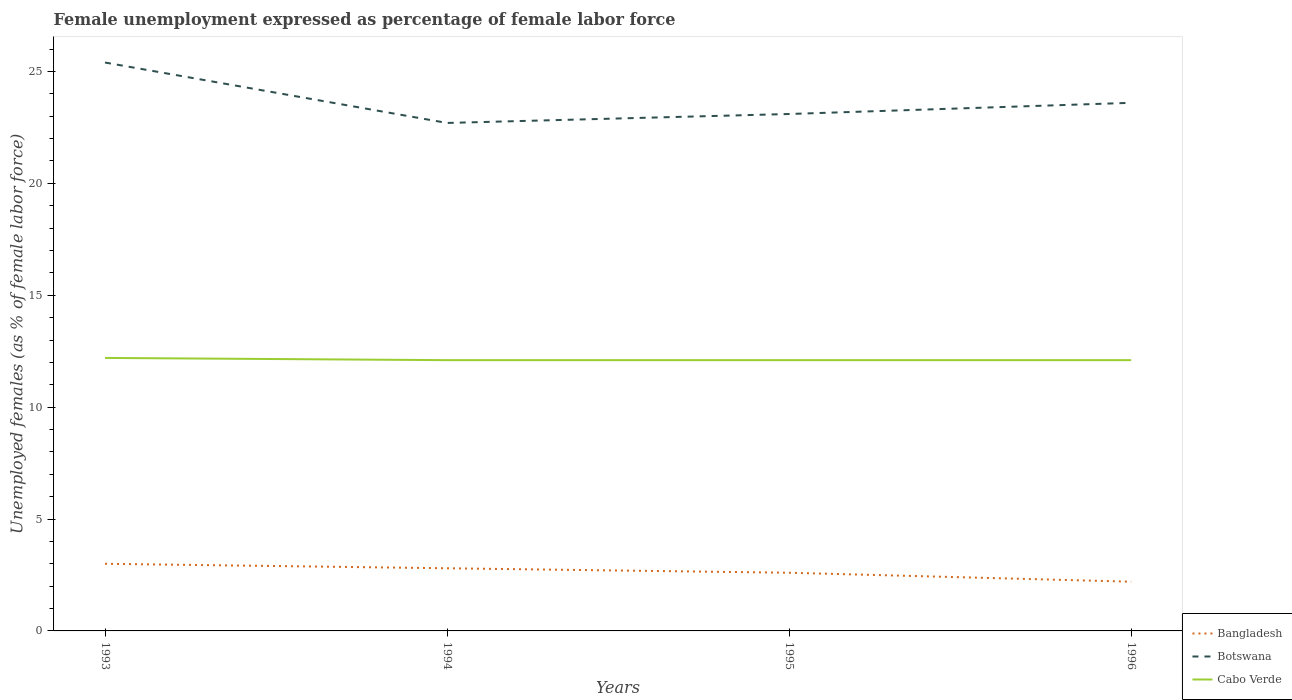Does the line corresponding to Bangladesh intersect with the line corresponding to Botswana?
Keep it short and to the point. No. Across all years, what is the maximum unemployment in females in in Cabo Verde?
Offer a terse response. 12.1. What is the total unemployment in females in in Botswana in the graph?
Keep it short and to the point. 1.8. What is the difference between the highest and the second highest unemployment in females in in Bangladesh?
Make the answer very short. 0.8. Is the unemployment in females in in Botswana strictly greater than the unemployment in females in in Cabo Verde over the years?
Keep it short and to the point. No. How many years are there in the graph?
Give a very brief answer. 4. How many legend labels are there?
Your response must be concise. 3. How are the legend labels stacked?
Your answer should be very brief. Vertical. What is the title of the graph?
Keep it short and to the point. Female unemployment expressed as percentage of female labor force. Does "Dominica" appear as one of the legend labels in the graph?
Offer a very short reply. No. What is the label or title of the X-axis?
Provide a short and direct response. Years. What is the label or title of the Y-axis?
Make the answer very short. Unemployed females (as % of female labor force). What is the Unemployed females (as % of female labor force) of Bangladesh in 1993?
Make the answer very short. 3. What is the Unemployed females (as % of female labor force) in Botswana in 1993?
Provide a short and direct response. 25.4. What is the Unemployed females (as % of female labor force) in Cabo Verde in 1993?
Your answer should be compact. 12.2. What is the Unemployed females (as % of female labor force) in Bangladesh in 1994?
Your answer should be compact. 2.8. What is the Unemployed females (as % of female labor force) in Botswana in 1994?
Provide a succinct answer. 22.7. What is the Unemployed females (as % of female labor force) of Cabo Verde in 1994?
Give a very brief answer. 12.1. What is the Unemployed females (as % of female labor force) of Bangladesh in 1995?
Your answer should be compact. 2.6. What is the Unemployed females (as % of female labor force) of Botswana in 1995?
Give a very brief answer. 23.1. What is the Unemployed females (as % of female labor force) of Cabo Verde in 1995?
Provide a succinct answer. 12.1. What is the Unemployed females (as % of female labor force) of Bangladesh in 1996?
Keep it short and to the point. 2.2. What is the Unemployed females (as % of female labor force) of Botswana in 1996?
Keep it short and to the point. 23.6. What is the Unemployed females (as % of female labor force) of Cabo Verde in 1996?
Keep it short and to the point. 12.1. Across all years, what is the maximum Unemployed females (as % of female labor force) in Botswana?
Provide a succinct answer. 25.4. Across all years, what is the maximum Unemployed females (as % of female labor force) in Cabo Verde?
Your answer should be compact. 12.2. Across all years, what is the minimum Unemployed females (as % of female labor force) of Bangladesh?
Make the answer very short. 2.2. Across all years, what is the minimum Unemployed females (as % of female labor force) of Botswana?
Make the answer very short. 22.7. Across all years, what is the minimum Unemployed females (as % of female labor force) in Cabo Verde?
Provide a succinct answer. 12.1. What is the total Unemployed females (as % of female labor force) in Botswana in the graph?
Provide a short and direct response. 94.8. What is the total Unemployed females (as % of female labor force) in Cabo Verde in the graph?
Make the answer very short. 48.5. What is the difference between the Unemployed females (as % of female labor force) of Bangladesh in 1993 and that in 1994?
Make the answer very short. 0.2. What is the difference between the Unemployed females (as % of female labor force) of Bangladesh in 1993 and that in 1995?
Keep it short and to the point. 0.4. What is the difference between the Unemployed females (as % of female labor force) in Botswana in 1993 and that in 1995?
Offer a very short reply. 2.3. What is the difference between the Unemployed females (as % of female labor force) of Cabo Verde in 1993 and that in 1996?
Offer a very short reply. 0.1. What is the difference between the Unemployed females (as % of female labor force) in Bangladesh in 1994 and that in 1995?
Make the answer very short. 0.2. What is the difference between the Unemployed females (as % of female labor force) of Bangladesh in 1994 and that in 1996?
Your answer should be very brief. 0.6. What is the difference between the Unemployed females (as % of female labor force) in Cabo Verde in 1995 and that in 1996?
Provide a succinct answer. 0. What is the difference between the Unemployed females (as % of female labor force) of Bangladesh in 1993 and the Unemployed females (as % of female labor force) of Botswana in 1994?
Make the answer very short. -19.7. What is the difference between the Unemployed females (as % of female labor force) of Botswana in 1993 and the Unemployed females (as % of female labor force) of Cabo Verde in 1994?
Offer a terse response. 13.3. What is the difference between the Unemployed females (as % of female labor force) of Bangladesh in 1993 and the Unemployed females (as % of female labor force) of Botswana in 1995?
Your response must be concise. -20.1. What is the difference between the Unemployed females (as % of female labor force) in Botswana in 1993 and the Unemployed females (as % of female labor force) in Cabo Verde in 1995?
Provide a succinct answer. 13.3. What is the difference between the Unemployed females (as % of female labor force) of Bangladesh in 1993 and the Unemployed females (as % of female labor force) of Botswana in 1996?
Give a very brief answer. -20.6. What is the difference between the Unemployed females (as % of female labor force) of Bangladesh in 1993 and the Unemployed females (as % of female labor force) of Cabo Verde in 1996?
Keep it short and to the point. -9.1. What is the difference between the Unemployed females (as % of female labor force) of Botswana in 1993 and the Unemployed females (as % of female labor force) of Cabo Verde in 1996?
Give a very brief answer. 13.3. What is the difference between the Unemployed females (as % of female labor force) of Bangladesh in 1994 and the Unemployed females (as % of female labor force) of Botswana in 1995?
Your response must be concise. -20.3. What is the difference between the Unemployed females (as % of female labor force) of Bangladesh in 1994 and the Unemployed females (as % of female labor force) of Cabo Verde in 1995?
Ensure brevity in your answer.  -9.3. What is the difference between the Unemployed females (as % of female labor force) in Bangladesh in 1994 and the Unemployed females (as % of female labor force) in Botswana in 1996?
Keep it short and to the point. -20.8. What is the difference between the Unemployed females (as % of female labor force) in Bangladesh in 1995 and the Unemployed females (as % of female labor force) in Botswana in 1996?
Your answer should be very brief. -21. What is the difference between the Unemployed females (as % of female labor force) of Bangladesh in 1995 and the Unemployed females (as % of female labor force) of Cabo Verde in 1996?
Your answer should be very brief. -9.5. What is the average Unemployed females (as % of female labor force) of Bangladesh per year?
Provide a succinct answer. 2.65. What is the average Unemployed females (as % of female labor force) in Botswana per year?
Your answer should be very brief. 23.7. What is the average Unemployed females (as % of female labor force) of Cabo Verde per year?
Ensure brevity in your answer.  12.12. In the year 1993, what is the difference between the Unemployed females (as % of female labor force) of Bangladesh and Unemployed females (as % of female labor force) of Botswana?
Offer a terse response. -22.4. In the year 1994, what is the difference between the Unemployed females (as % of female labor force) of Bangladesh and Unemployed females (as % of female labor force) of Botswana?
Keep it short and to the point. -19.9. In the year 1994, what is the difference between the Unemployed females (as % of female labor force) of Botswana and Unemployed females (as % of female labor force) of Cabo Verde?
Keep it short and to the point. 10.6. In the year 1995, what is the difference between the Unemployed females (as % of female labor force) of Bangladesh and Unemployed females (as % of female labor force) of Botswana?
Offer a very short reply. -20.5. In the year 1995, what is the difference between the Unemployed females (as % of female labor force) of Botswana and Unemployed females (as % of female labor force) of Cabo Verde?
Keep it short and to the point. 11. In the year 1996, what is the difference between the Unemployed females (as % of female labor force) in Bangladesh and Unemployed females (as % of female labor force) in Botswana?
Ensure brevity in your answer.  -21.4. In the year 1996, what is the difference between the Unemployed females (as % of female labor force) of Bangladesh and Unemployed females (as % of female labor force) of Cabo Verde?
Offer a very short reply. -9.9. In the year 1996, what is the difference between the Unemployed females (as % of female labor force) of Botswana and Unemployed females (as % of female labor force) of Cabo Verde?
Your response must be concise. 11.5. What is the ratio of the Unemployed females (as % of female labor force) of Bangladesh in 1993 to that in 1994?
Provide a succinct answer. 1.07. What is the ratio of the Unemployed females (as % of female labor force) of Botswana in 1993 to that in 1994?
Offer a terse response. 1.12. What is the ratio of the Unemployed females (as % of female labor force) of Cabo Verde in 1993 to that in 1994?
Provide a succinct answer. 1.01. What is the ratio of the Unemployed females (as % of female labor force) of Bangladesh in 1993 to that in 1995?
Offer a terse response. 1.15. What is the ratio of the Unemployed females (as % of female labor force) in Botswana in 1993 to that in 1995?
Keep it short and to the point. 1.1. What is the ratio of the Unemployed females (as % of female labor force) of Cabo Verde in 1993 to that in 1995?
Make the answer very short. 1.01. What is the ratio of the Unemployed females (as % of female labor force) of Bangladesh in 1993 to that in 1996?
Make the answer very short. 1.36. What is the ratio of the Unemployed females (as % of female labor force) in Botswana in 1993 to that in 1996?
Make the answer very short. 1.08. What is the ratio of the Unemployed females (as % of female labor force) of Cabo Verde in 1993 to that in 1996?
Give a very brief answer. 1.01. What is the ratio of the Unemployed females (as % of female labor force) of Bangladesh in 1994 to that in 1995?
Your answer should be very brief. 1.08. What is the ratio of the Unemployed females (as % of female labor force) of Botswana in 1994 to that in 1995?
Ensure brevity in your answer.  0.98. What is the ratio of the Unemployed females (as % of female labor force) of Bangladesh in 1994 to that in 1996?
Your response must be concise. 1.27. What is the ratio of the Unemployed females (as % of female labor force) of Botswana in 1994 to that in 1996?
Keep it short and to the point. 0.96. What is the ratio of the Unemployed females (as % of female labor force) in Bangladesh in 1995 to that in 1996?
Ensure brevity in your answer.  1.18. What is the ratio of the Unemployed females (as % of female labor force) of Botswana in 1995 to that in 1996?
Your answer should be very brief. 0.98. What is the difference between the highest and the second highest Unemployed females (as % of female labor force) of Botswana?
Your answer should be compact. 1.8. What is the difference between the highest and the second highest Unemployed females (as % of female labor force) of Cabo Verde?
Provide a short and direct response. 0.1. What is the difference between the highest and the lowest Unemployed females (as % of female labor force) in Cabo Verde?
Your answer should be compact. 0.1. 